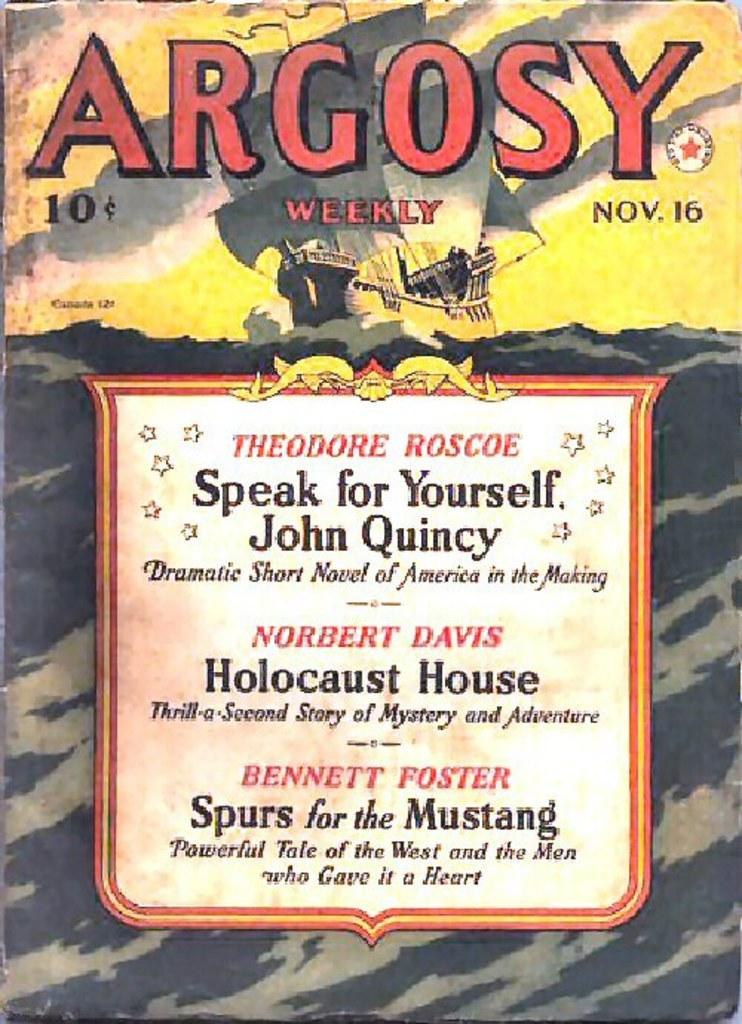<image>
Write a terse but informative summary of the picture. a copy of Argosy weekly, an old magazine. 